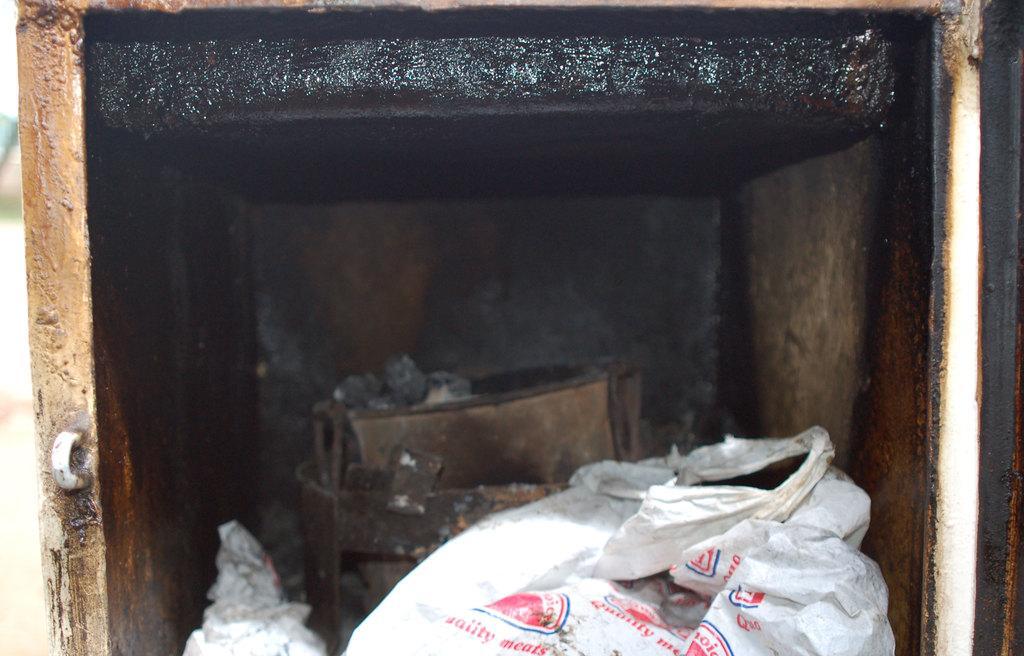How would you summarize this image in a sentence or two? In the picture we can see some covers and some other items in a box. 